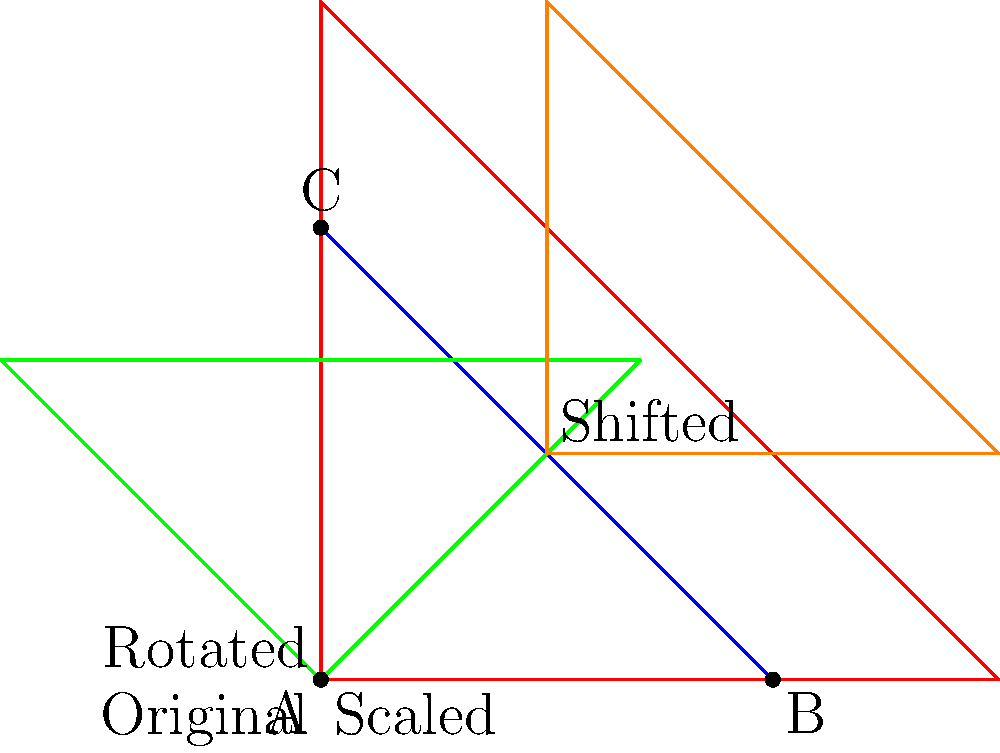In the context of non-Euclidean transformations illustrating the evolution of gender norms across cultures, which transformation in the diagram best represents the gradual shift in societal perceptions of gender roles over time? To answer this question, let's analyze each transformation in the context of gender norm evolution:

1. Blue triangle (Original): Represents the initial state of gender norms in a society.

2. Red triangle (Scaled): This transformation enlarges the original triangle uniformly. In the context of gender norms, this could represent an amplification or exaggeration of existing norms, which is not typically how gender perceptions evolve.

3. Green triangle (Rotated): This transformation rotates the original triangle by 45 degrees. While this represents a change, it's a sudden and complete shift, which doesn't align with the typically gradual nature of societal changes in gender perception.

4. Orange triangle (Shifted): This transformation moves the original triangle slightly in both the x and y directions. This subtle shift best represents the gradual and continuous nature of how gender norms tend to evolve in societies over time.

The shifted (orange) triangle best represents the gradual shift in societal perceptions of gender roles because:
1. It maintains the overall structure (shape) of the original norms.
2. It shows a subtle but clear movement from the original position, indicating change.
3. The change is not drastic or sudden, aligning with the typically slow pace of societal shifts in gender perceptions.

Therefore, the shifted (orange) triangle is the most appropriate representation of the gradual evolution of gender norms across cultures.
Answer: Shifted (orange) triangle 